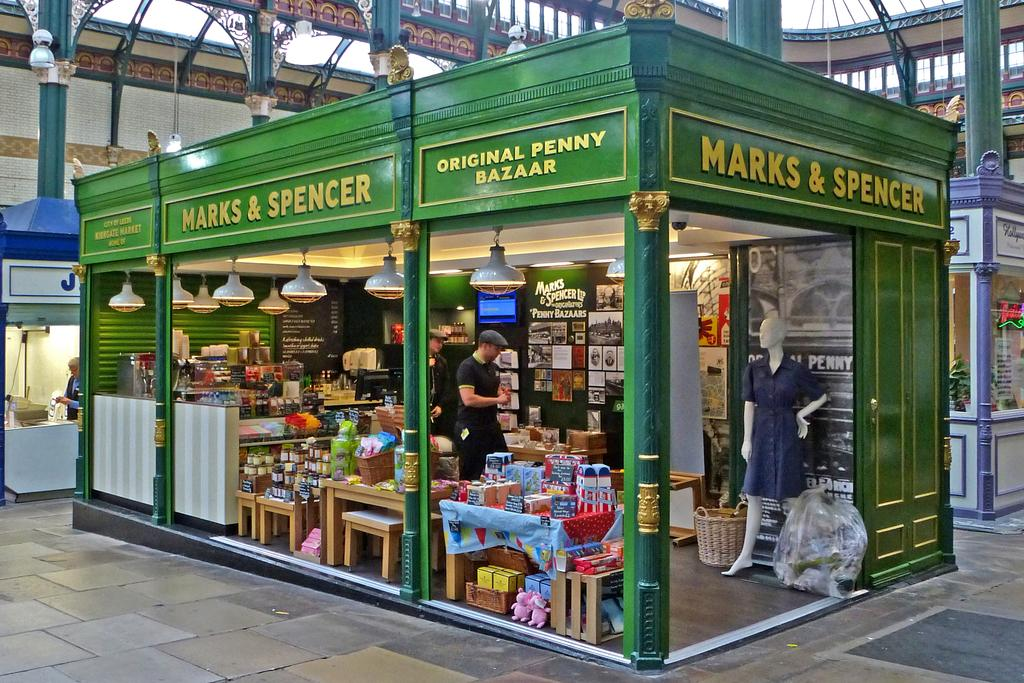<image>
Give a short and clear explanation of the subsequent image. A green small Marks & Spencer store building is inside a bigger building. 